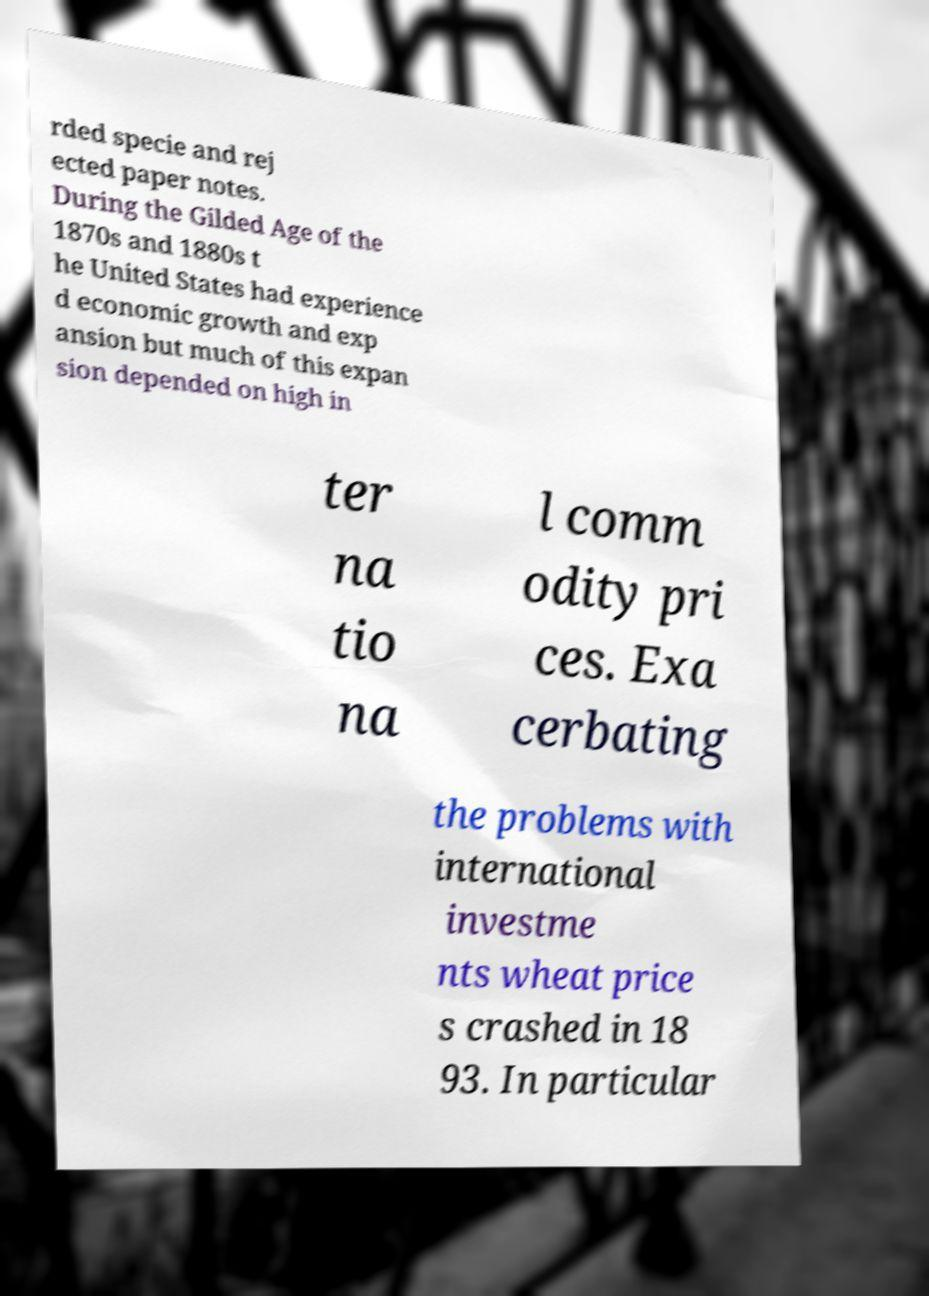Could you assist in decoding the text presented in this image and type it out clearly? rded specie and rej ected paper notes. During the Gilded Age of the 1870s and 1880s t he United States had experience d economic growth and exp ansion but much of this expan sion depended on high in ter na tio na l comm odity pri ces. Exa cerbating the problems with international investme nts wheat price s crashed in 18 93. In particular 